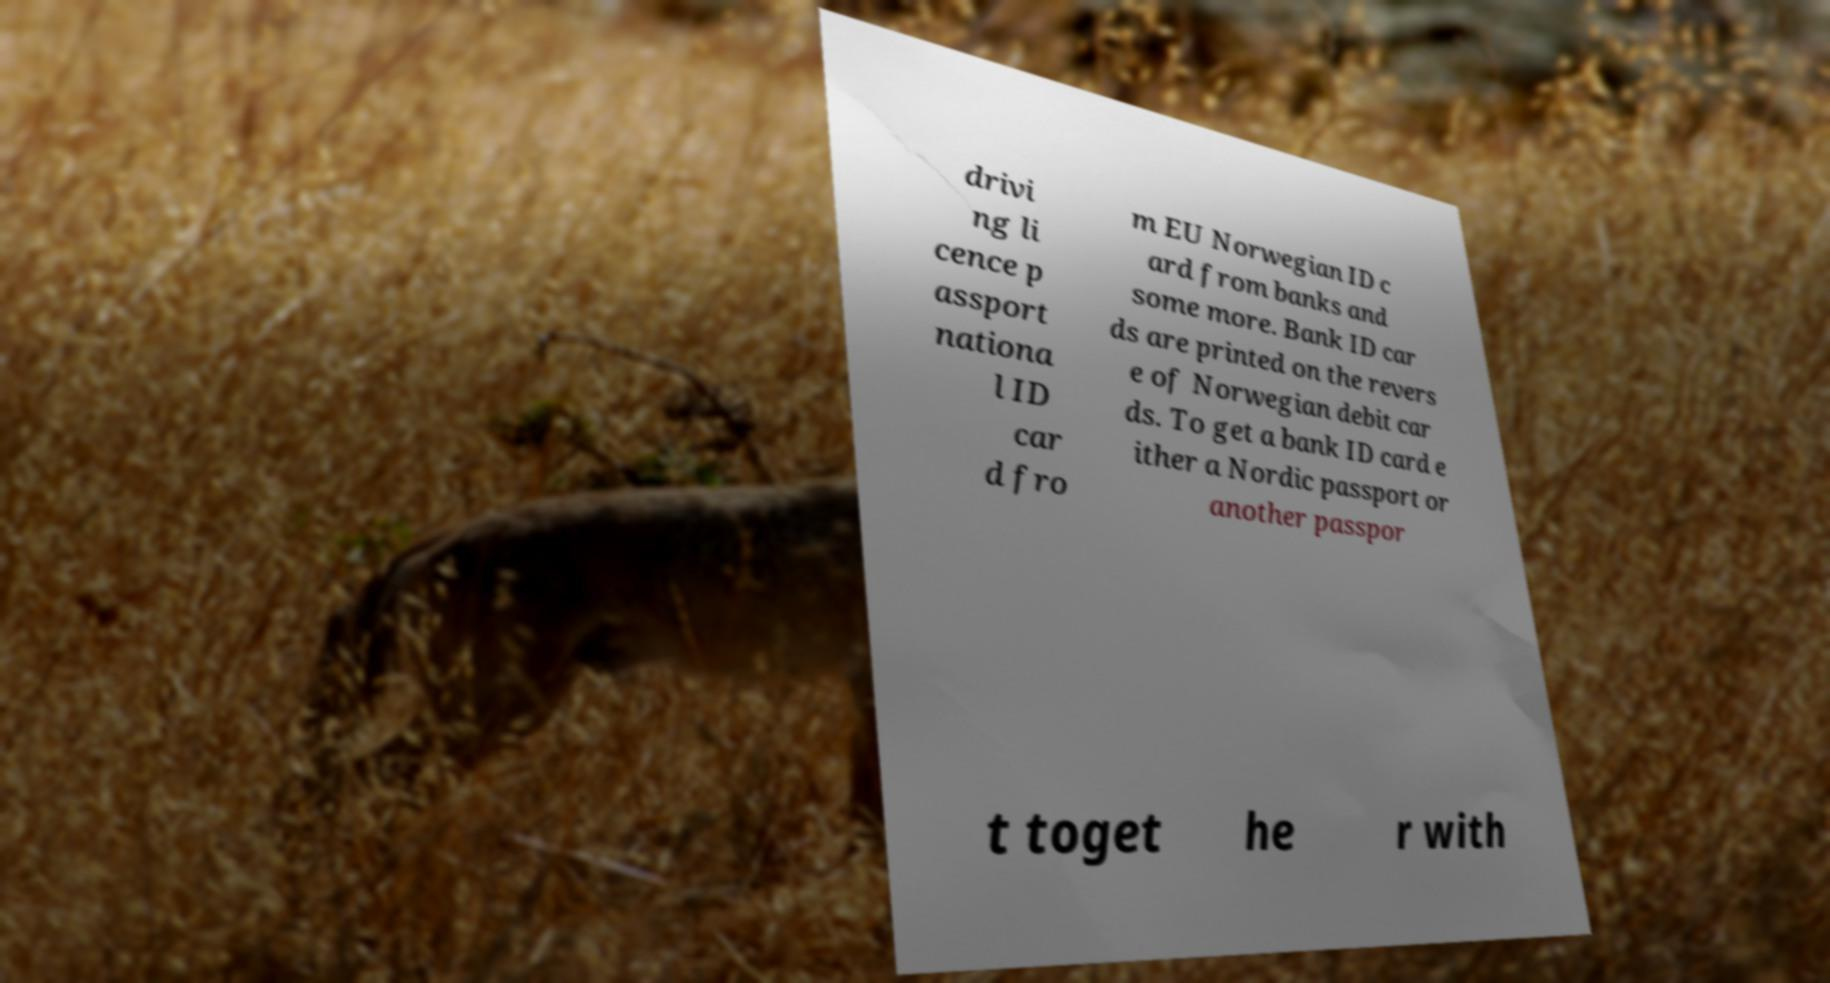There's text embedded in this image that I need extracted. Can you transcribe it verbatim? drivi ng li cence p assport nationa l ID car d fro m EU Norwegian ID c ard from banks and some more. Bank ID car ds are printed on the revers e of Norwegian debit car ds. To get a bank ID card e ither a Nordic passport or another passpor t toget he r with 